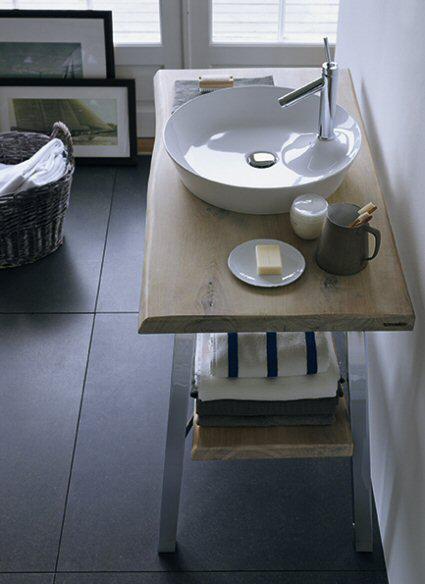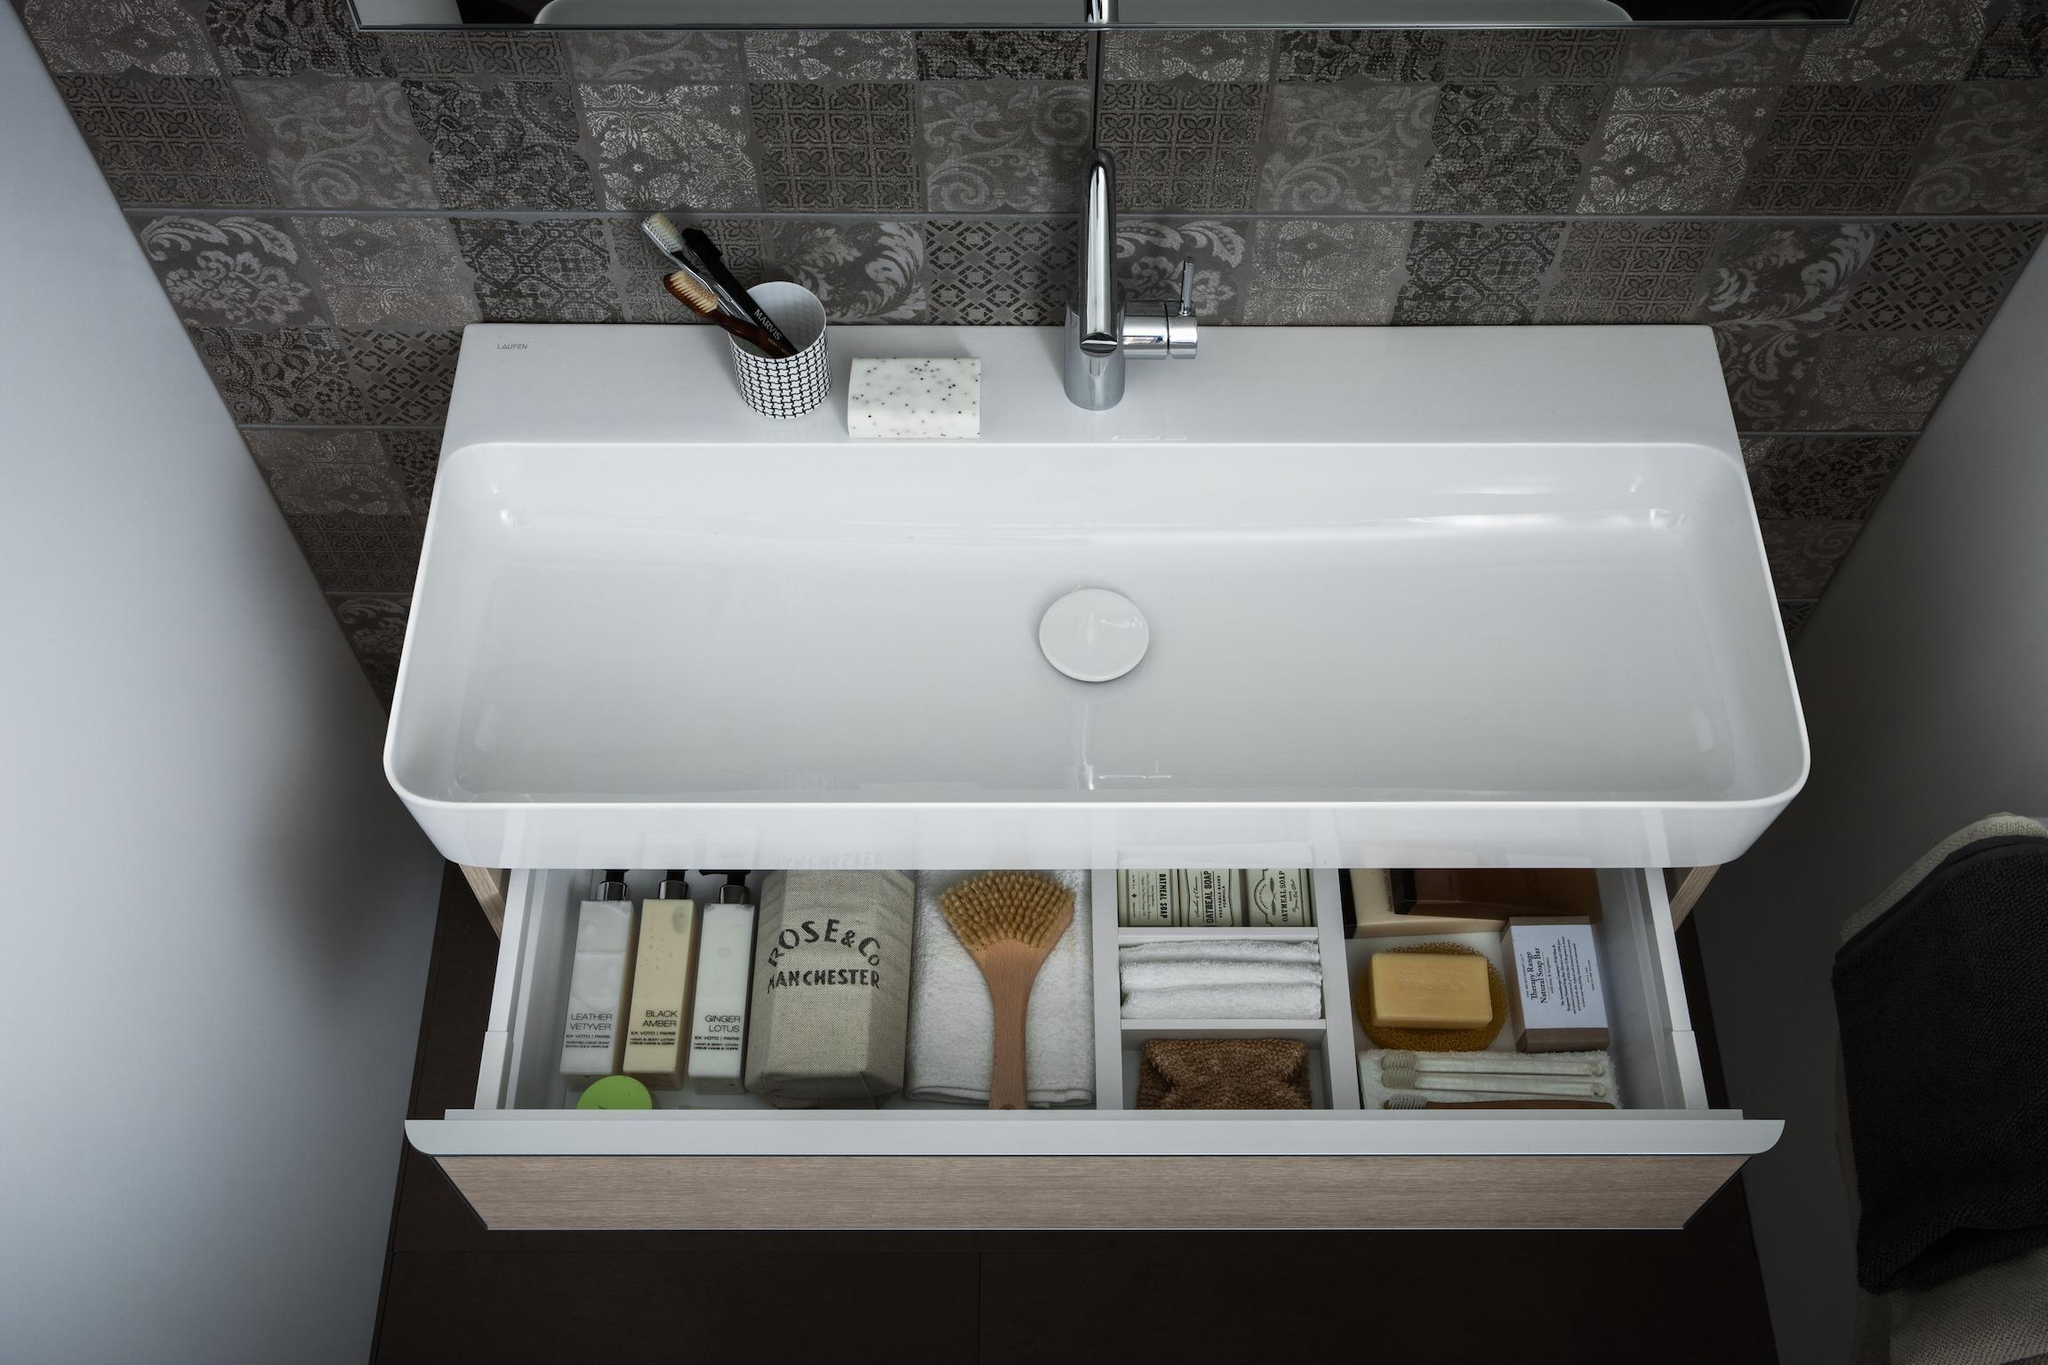The first image is the image on the left, the second image is the image on the right. Assess this claim about the two images: "There is a mirror positioned above every sink basin.". Correct or not? Answer yes or no. No. The first image is the image on the left, the second image is the image on the right. For the images displayed, is the sentence "The left image features at least one round sink inset in white and mounted on the wall, and the right image features a rectangular white sink." factually correct? Answer yes or no. No. 